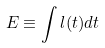Convert formula to latex. <formula><loc_0><loc_0><loc_500><loc_500>E \equiv \int l ( t ) d t</formula> 